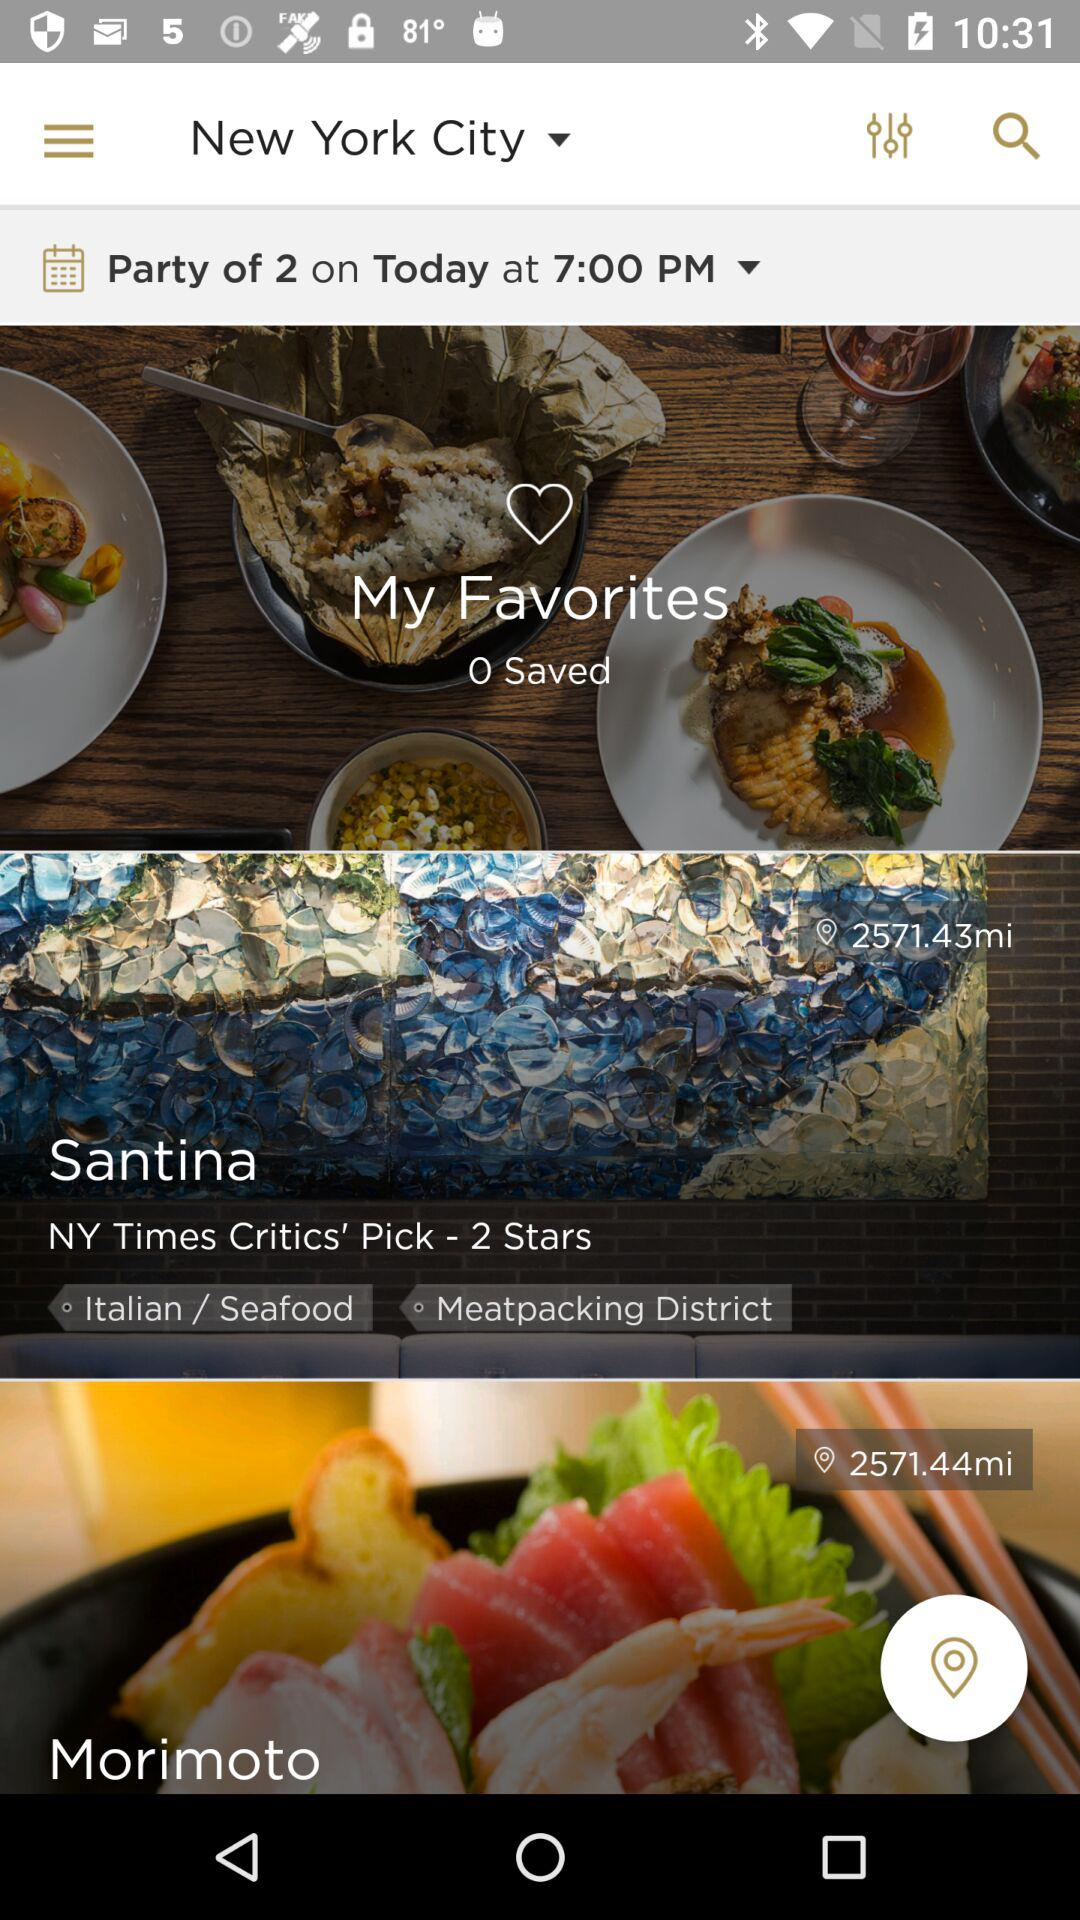What is the time for the "Party of 2"? The time for the "Party of 2" is 7:00 PM. 